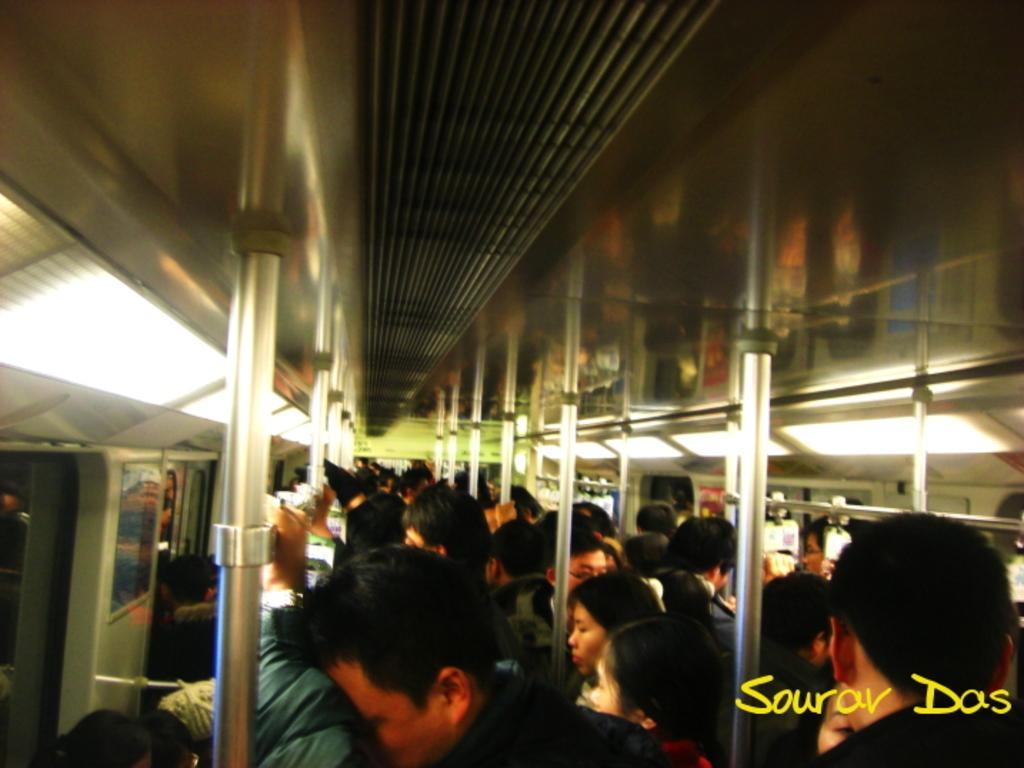Who or what can be seen in the image? There are people in the image. What are the people doing in the image? The people are standing in a train. What sign can be seen on the platform as the train approaches? There is no platform or sign visible in the image; it only shows people standing in a train. 